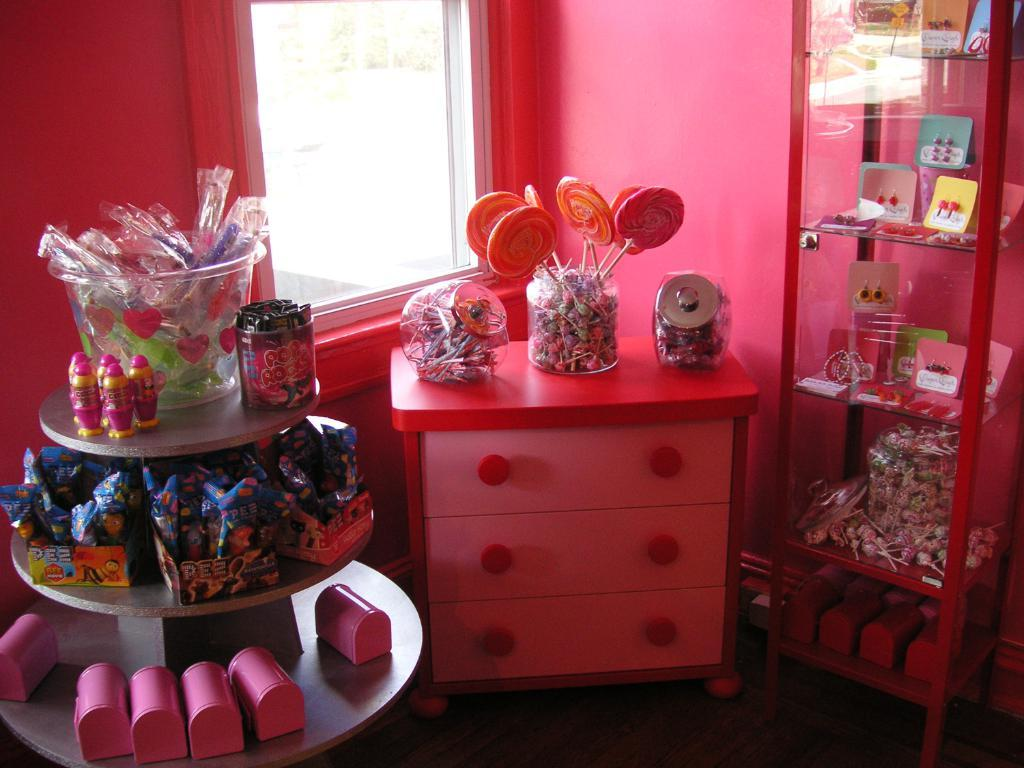What type of surface is visible in the image? There is a floor in the image. What type of furniture is present in the image? There is a drawer and racks in the image. What items can be seen on the racks? There are bottles and boxes in the image. Are there any other objects visible in the image? Yes, there are other objects in the image. What can be seen in the background of the image? There is a wall and a window in the background of the image. How many beans are visible on the floor in the image? There are no beans visible on the floor in the image. What type of rabbit can be seen interacting with the drawer in the image? There is no rabbit present in the image; it only features a drawer, racks, bottles, boxes, and other objects. 